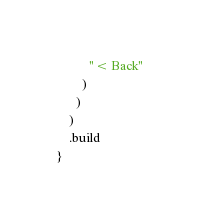<code> <loc_0><loc_0><loc_500><loc_500><_Scala_>          "< Back"
        )
      )
    )
    .build
}
</code> 